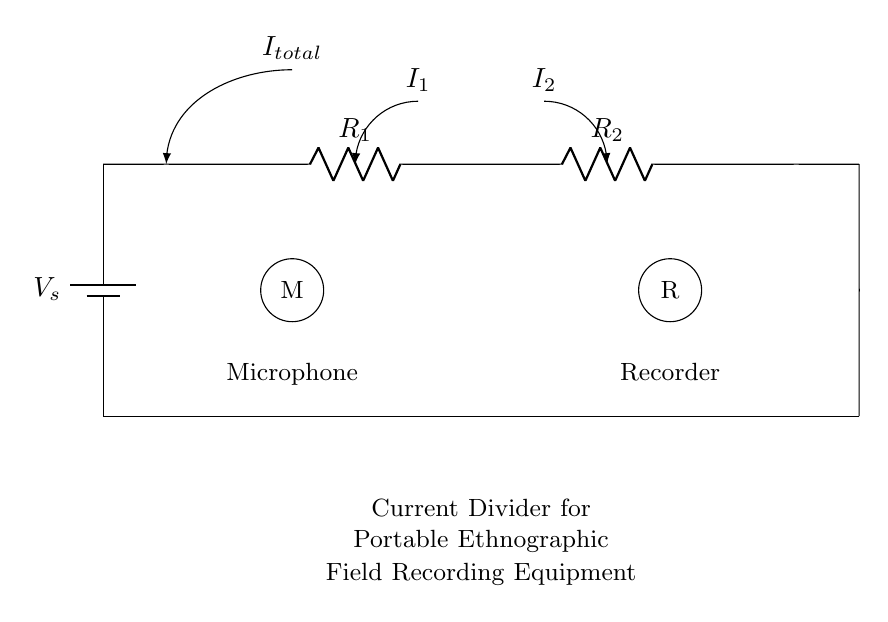What is the total current in the circuit? The total current is represented by the label I total in the circuit diagram, indicating that it is the current entering the first resistor.
Answer: I total What do R1 and R2 represent? R1 and R2 are labels for the two resistors in the circuit which are part of the current divider.
Answer: Resistors What is connected to the first branch of the current divider? The first branch of the current divider is connected to a microphone, as indicated by the label M.
Answer: Microphone What happens to the current as it passes through R1 and R2? The current splits into two paths after R1, denoted by the currents I1 and I2 in the diagram, which reflects the principle of a current divider.
Answer: Splits What is the purpose of this circuit in the context of ethnographic research? This circuit is designed to power portable field recording equipment, enabling ethnographers to capture audio in various environments.
Answer: Field recording How are the components in the circuit grounded? The components are grounded through a common connection point at the bottom of the circuit, shown by the short line connecting them to the ground.
Answer: Common connection 